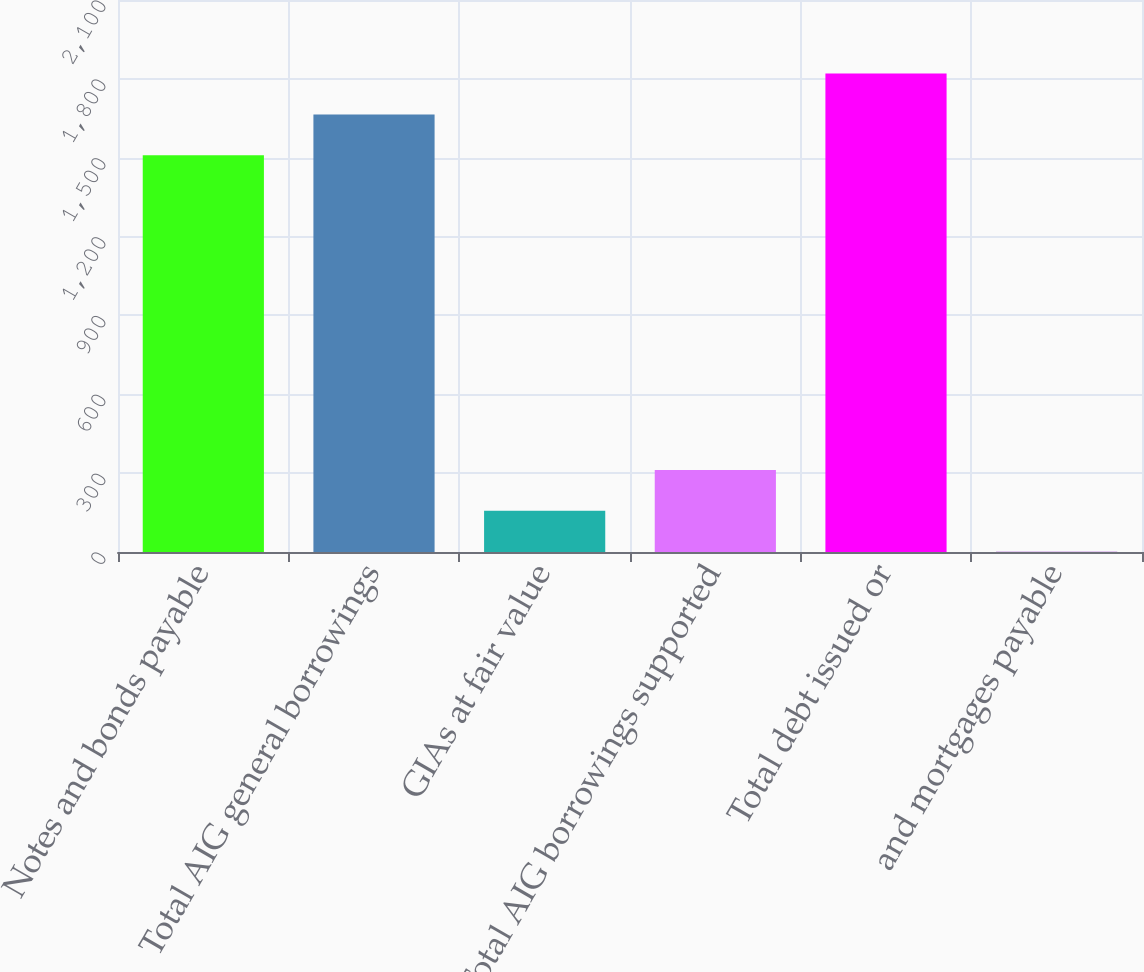Convert chart to OTSL. <chart><loc_0><loc_0><loc_500><loc_500><bar_chart><fcel>Notes and bonds payable<fcel>Total AIG general borrowings<fcel>GIAs at fair value<fcel>Total AIG borrowings supported<fcel>Total debt issued or<fcel>and mortgages payable<nl><fcel>1509<fcel>1664.6<fcel>156.6<fcel>312.2<fcel>1820.2<fcel>1<nl></chart> 